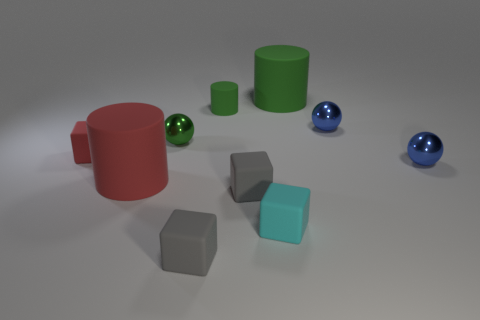Does the tiny green cylinder have the same material as the small cube behind the red cylinder?
Give a very brief answer. Yes. There is another large thing that is the same shape as the big red rubber object; what material is it?
Your response must be concise. Rubber. Is the red thing right of the small red rubber cube made of the same material as the tiny blue ball that is behind the red block?
Ensure brevity in your answer.  No. There is a tiny matte object that is behind the blue ball that is left of the tiny blue metal ball that is in front of the green metal ball; what color is it?
Provide a succinct answer. Green. What number of other things are there of the same shape as the tiny green metallic thing?
Ensure brevity in your answer.  2. What number of things are either large green rubber things or cylinders that are in front of the big green matte object?
Your answer should be very brief. 3. Are there any cyan blocks of the same size as the red matte cube?
Provide a succinct answer. Yes. Does the large red thing have the same material as the small cyan cube?
Ensure brevity in your answer.  Yes. What number of things are rubber blocks or yellow shiny cylinders?
Your answer should be compact. 4. What is the size of the red cylinder?
Provide a short and direct response. Large. 